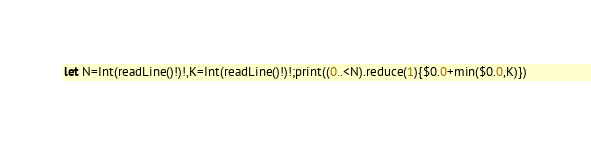Convert code to text. <code><loc_0><loc_0><loc_500><loc_500><_Swift_>let N=Int(readLine()!)!,K=Int(readLine()!)!;print((0..<N).reduce(1){$0.0+min($0.0,K)})</code> 